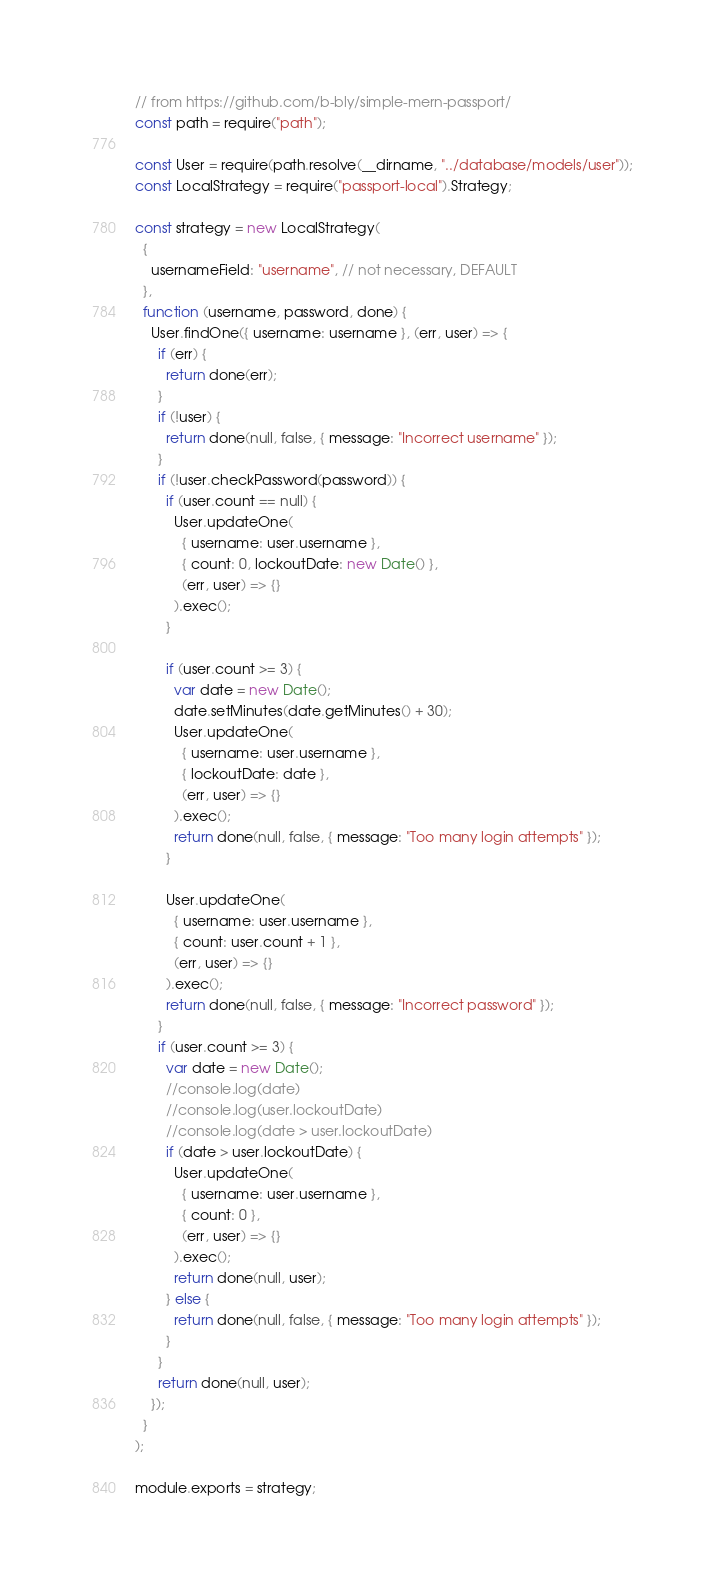<code> <loc_0><loc_0><loc_500><loc_500><_JavaScript_>// from https://github.com/b-bly/simple-mern-passport/
const path = require("path");

const User = require(path.resolve(__dirname, "../database/models/user"));
const LocalStrategy = require("passport-local").Strategy;

const strategy = new LocalStrategy(
  {
    usernameField: "username", // not necessary, DEFAULT
  },
  function (username, password, done) {
    User.findOne({ username: username }, (err, user) => {
      if (err) {
        return done(err);
      }
      if (!user) {
        return done(null, false, { message: "Incorrect username" });
      }
      if (!user.checkPassword(password)) {
        if (user.count == null) {
          User.updateOne(
            { username: user.username },
            { count: 0, lockoutDate: new Date() },
            (err, user) => {}
          ).exec();
        }

        if (user.count >= 3) {
          var date = new Date();
          date.setMinutes(date.getMinutes() + 30);
          User.updateOne(
            { username: user.username },
            { lockoutDate: date },
            (err, user) => {}
          ).exec();
          return done(null, false, { message: "Too many login attempts" });
        }

        User.updateOne(
          { username: user.username },
          { count: user.count + 1 },
          (err, user) => {}
        ).exec();
        return done(null, false, { message: "Incorrect password" });
      }
      if (user.count >= 3) {
        var date = new Date();
        //console.log(date)
        //console.log(user.lockoutDate)
        //console.log(date > user.lockoutDate)
        if (date > user.lockoutDate) {
          User.updateOne(
            { username: user.username },
            { count: 0 },
            (err, user) => {}
          ).exec();
          return done(null, user);
        } else {
          return done(null, false, { message: "Too many login attempts" });
        }
      }
      return done(null, user);
    });
  }
);

module.exports = strategy;
</code> 